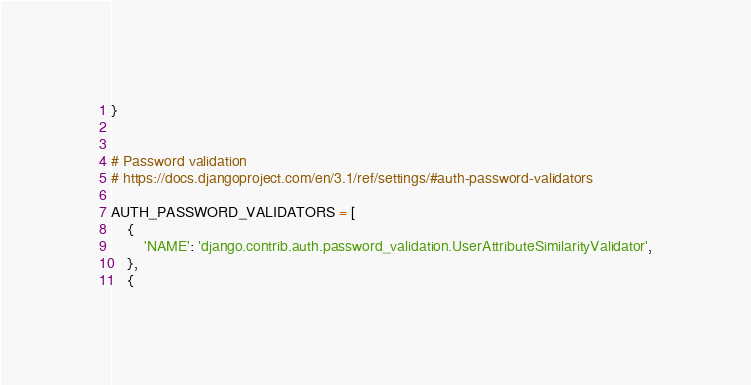<code> <loc_0><loc_0><loc_500><loc_500><_Python_>}


# Password validation
# https://docs.djangoproject.com/en/3.1/ref/settings/#auth-password-validators

AUTH_PASSWORD_VALIDATORS = [
    {
        'NAME': 'django.contrib.auth.password_validation.UserAttributeSimilarityValidator',
    },
    {</code> 